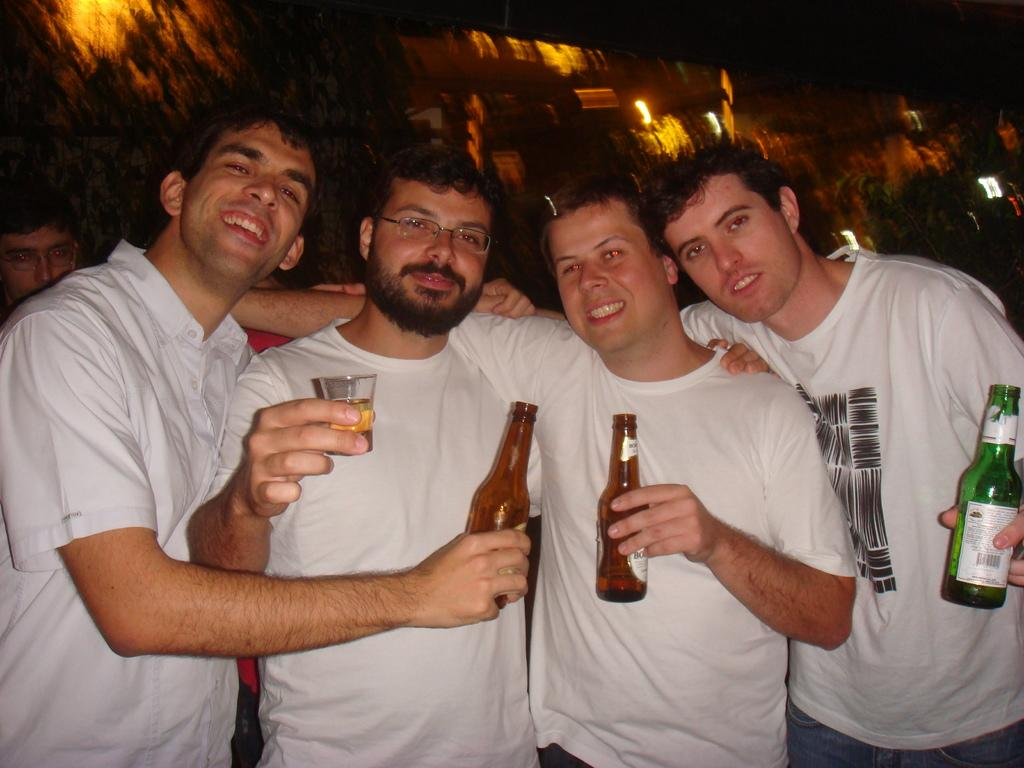Who or what can be seen in the image? There are people in the image. What are the people doing in the image? The people are standing. What objects are present in the image besides the people? There is a bottle and a glass in the image. What type of wax is being used to transport the people in the image? There is no wax or transportation depicted in the image; it simply shows people standing. 